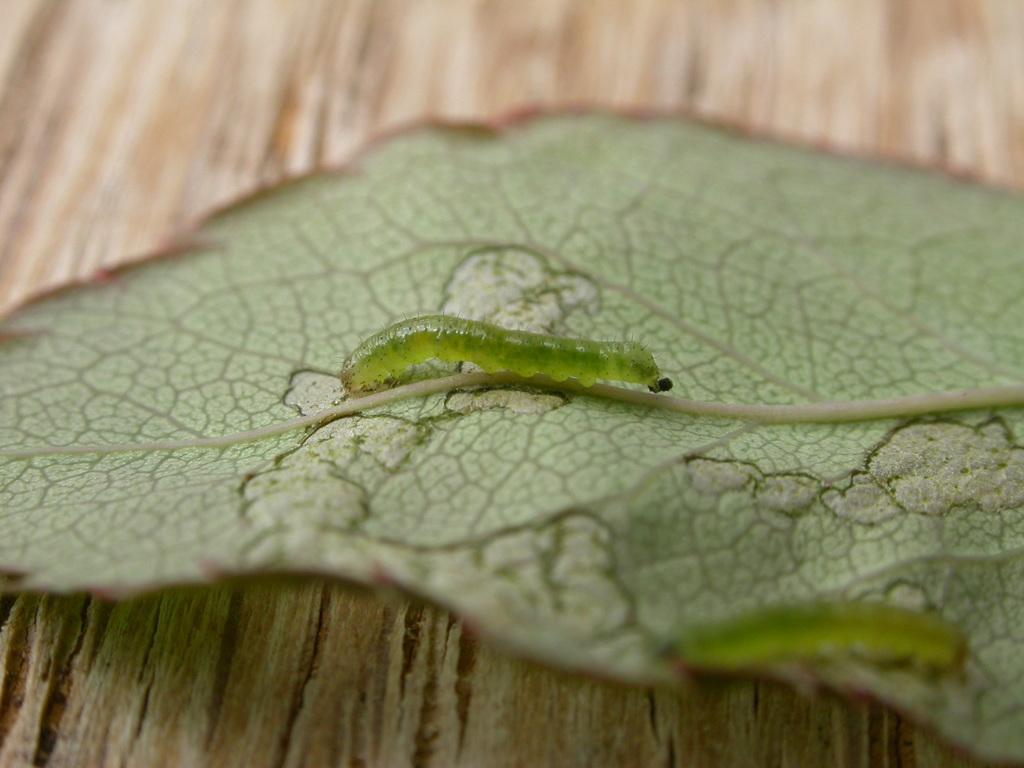How would you summarize this image in a sentence or two? In this image we can see insects on the leaf placed on the surface. 